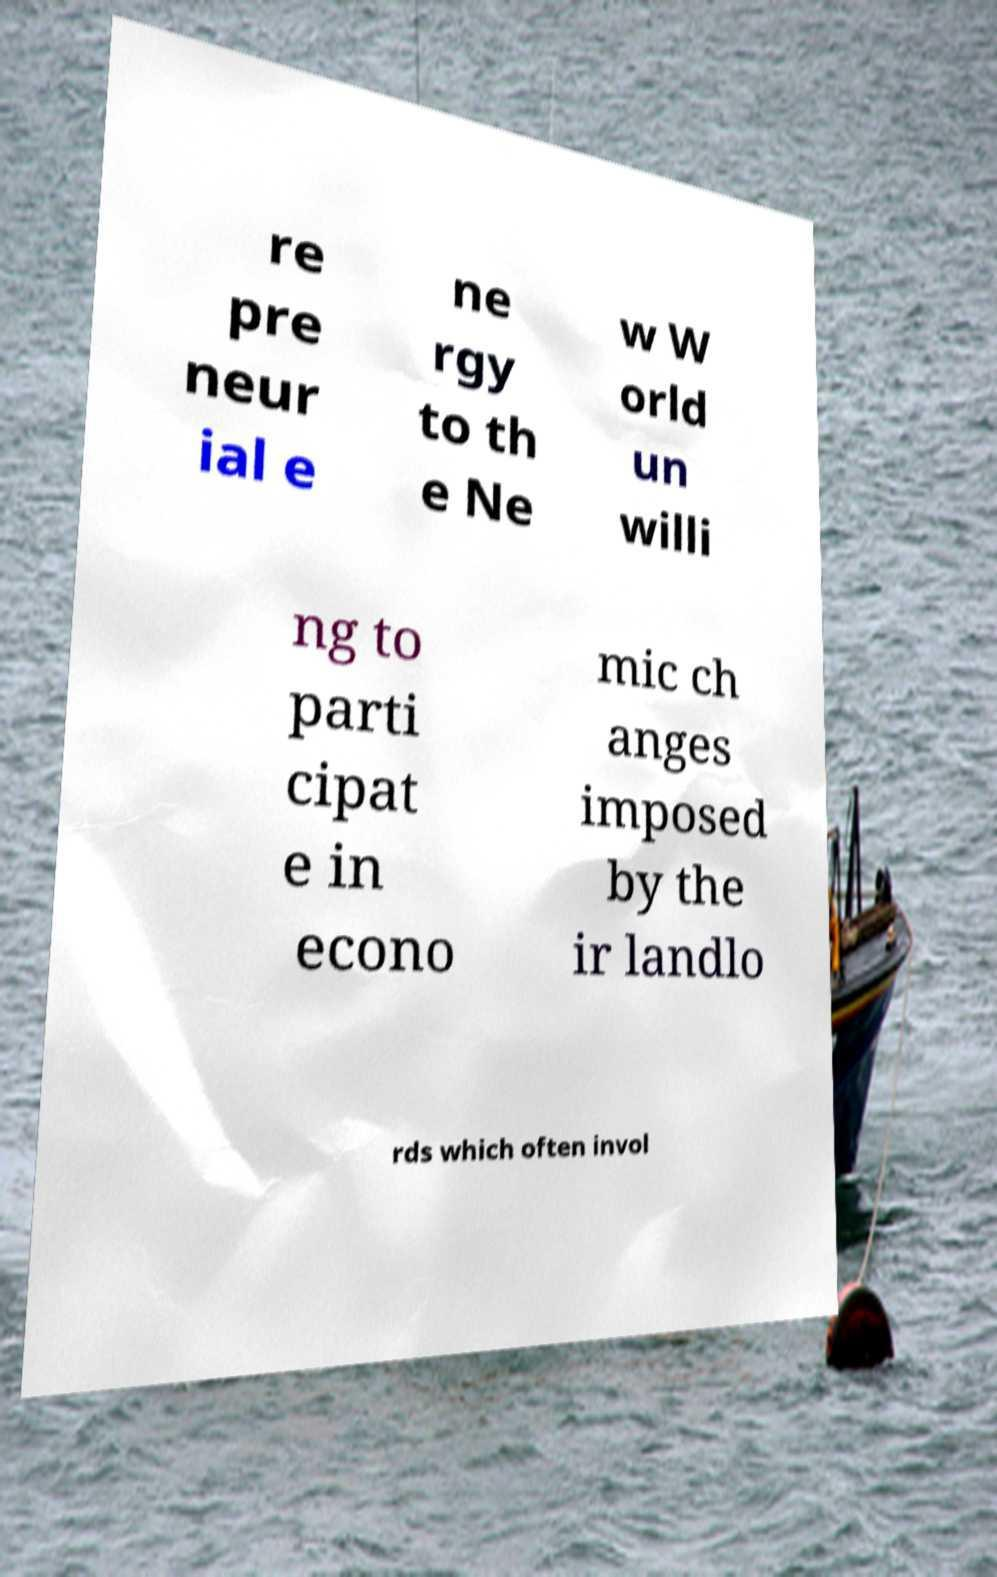What messages or text are displayed in this image? I need them in a readable, typed format. re pre neur ial e ne rgy to th e Ne w W orld un willi ng to parti cipat e in econo mic ch anges imposed by the ir landlo rds which often invol 